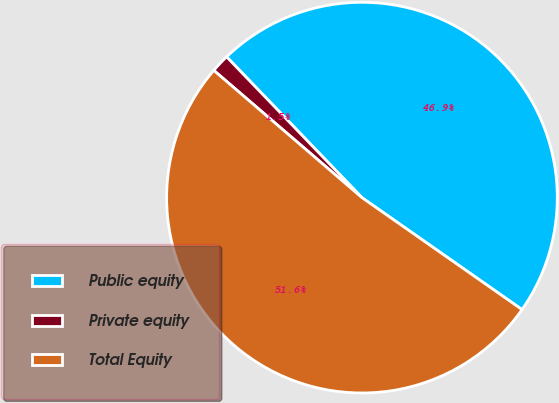<chart> <loc_0><loc_0><loc_500><loc_500><pie_chart><fcel>Public equity<fcel>Private equity<fcel>Total Equity<nl><fcel>46.9%<fcel>1.52%<fcel>51.58%<nl></chart> 